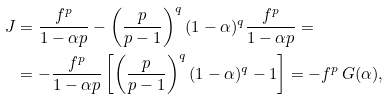<formula> <loc_0><loc_0><loc_500><loc_500>J & = \frac { f ^ { p } } { 1 - \alpha p } - \left ( \frac { p } { p - 1 } \right ) ^ { q } ( 1 - \alpha ) ^ { q } \frac { f ^ { p } } { 1 - \alpha p } = \\ & = - \frac { f ^ { p } } { 1 - \alpha p } \left [ \left ( \frac { p } { p - 1 } \right ) ^ { q } ( 1 - \alpha ) ^ { q } - 1 \right ] = - f ^ { p } \, G ( \alpha ) ,</formula> 